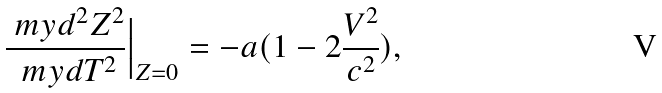<formula> <loc_0><loc_0><loc_500><loc_500>\frac { \ m y d ^ { 2 } Z ^ { 2 } } { \ m y d T ^ { 2 } } \Big | _ { Z = 0 } = - a ( 1 - 2 \frac { V ^ { 2 } } { c ^ { 2 } } ) ,</formula> 